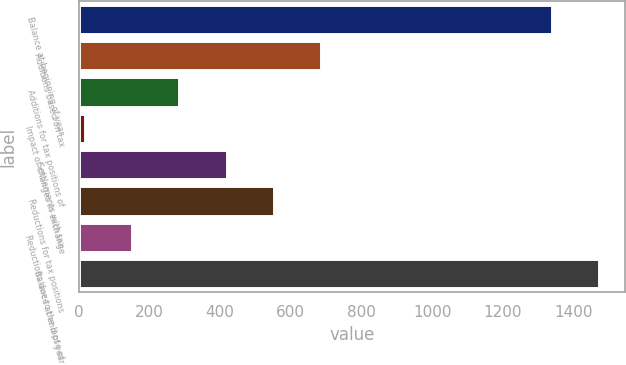Convert chart to OTSL. <chart><loc_0><loc_0><loc_500><loc_500><bar_chart><fcel>Balance at beginning of year<fcel>Additions based on tax<fcel>Additions for tax positions of<fcel>Impact of changes in exchange<fcel>Settlements with tax<fcel>Reductions for tax positions<fcel>Reductions due to the lapse of<fcel>Balance at end of year<nl><fcel>1338<fcel>685.5<fcel>285<fcel>18<fcel>418.5<fcel>552<fcel>151.5<fcel>1471.5<nl></chart> 